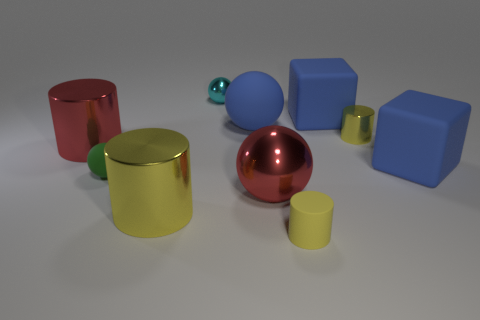Subtract all gray cubes. How many yellow cylinders are left? 3 Subtract all red cylinders. How many cylinders are left? 3 Subtract 1 spheres. How many spheres are left? 3 Subtract all purple cylinders. Subtract all blue spheres. How many cylinders are left? 4 Subtract all spheres. How many objects are left? 6 Subtract all rubber cylinders. Subtract all blue matte things. How many objects are left? 6 Add 8 tiny yellow rubber cylinders. How many tiny yellow rubber cylinders are left? 9 Add 2 large blue objects. How many large blue objects exist? 5 Subtract 0 gray blocks. How many objects are left? 10 